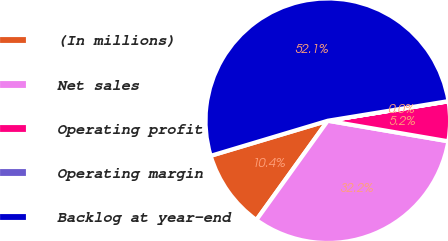Convert chart to OTSL. <chart><loc_0><loc_0><loc_500><loc_500><pie_chart><fcel>(In millions)<fcel>Net sales<fcel>Operating profit<fcel>Operating margin<fcel>Backlog at year-end<nl><fcel>10.44%<fcel>32.24%<fcel>5.23%<fcel>0.03%<fcel>52.07%<nl></chart> 